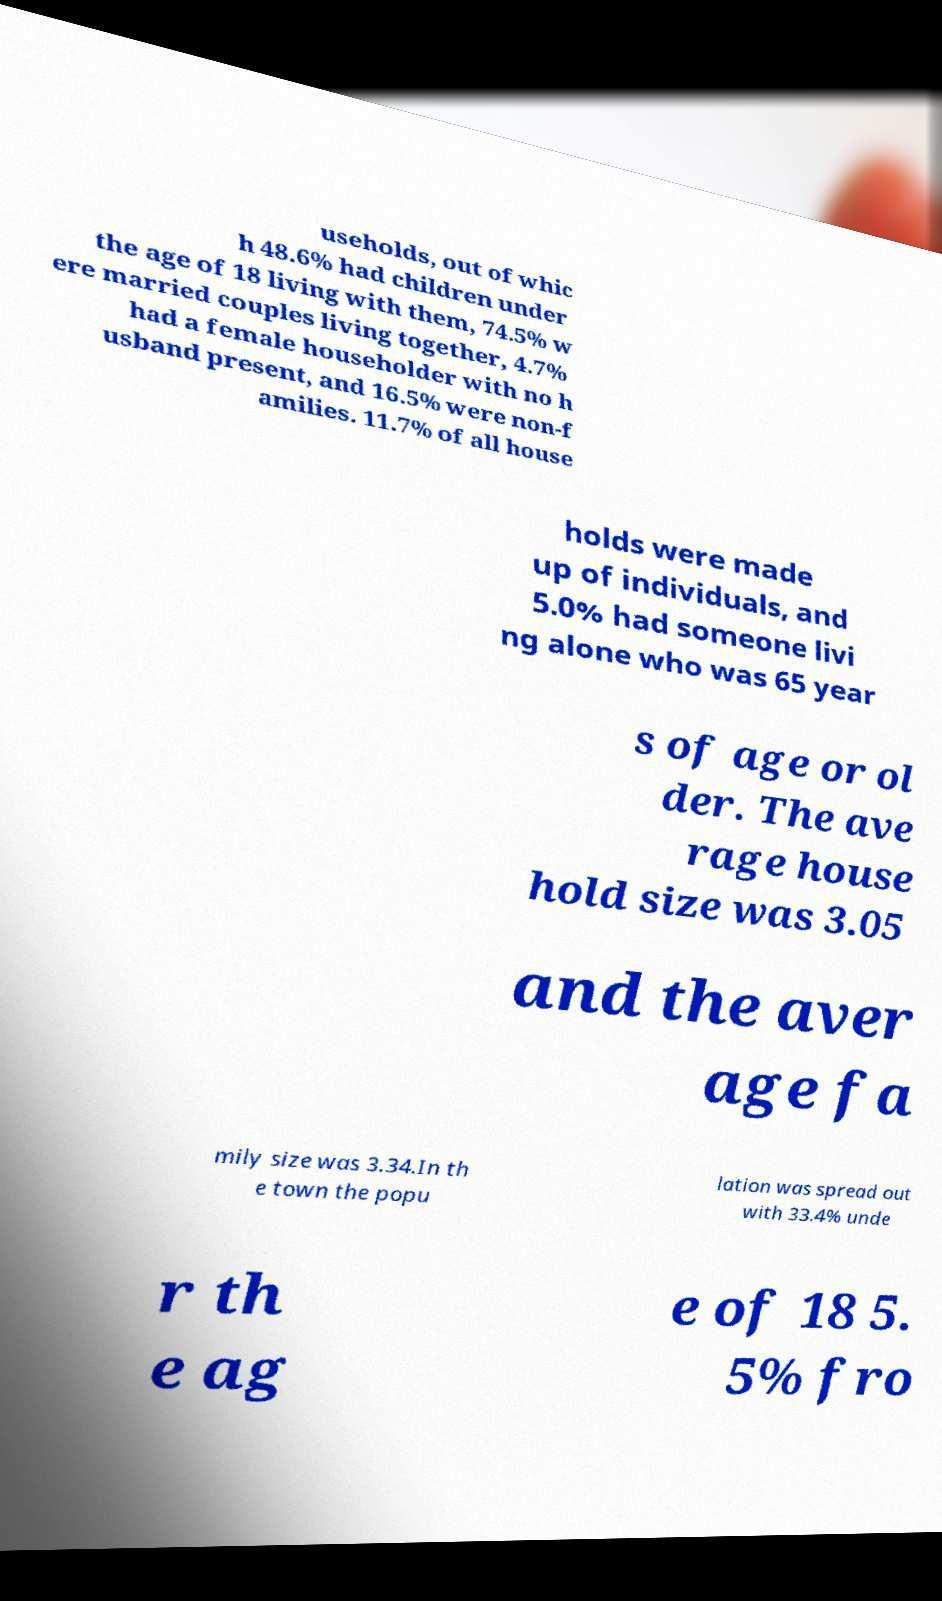I need the written content from this picture converted into text. Can you do that? useholds, out of whic h 48.6% had children under the age of 18 living with them, 74.5% w ere married couples living together, 4.7% had a female householder with no h usband present, and 16.5% were non-f amilies. 11.7% of all house holds were made up of individuals, and 5.0% had someone livi ng alone who was 65 year s of age or ol der. The ave rage house hold size was 3.05 and the aver age fa mily size was 3.34.In th e town the popu lation was spread out with 33.4% unde r th e ag e of 18 5. 5% fro 